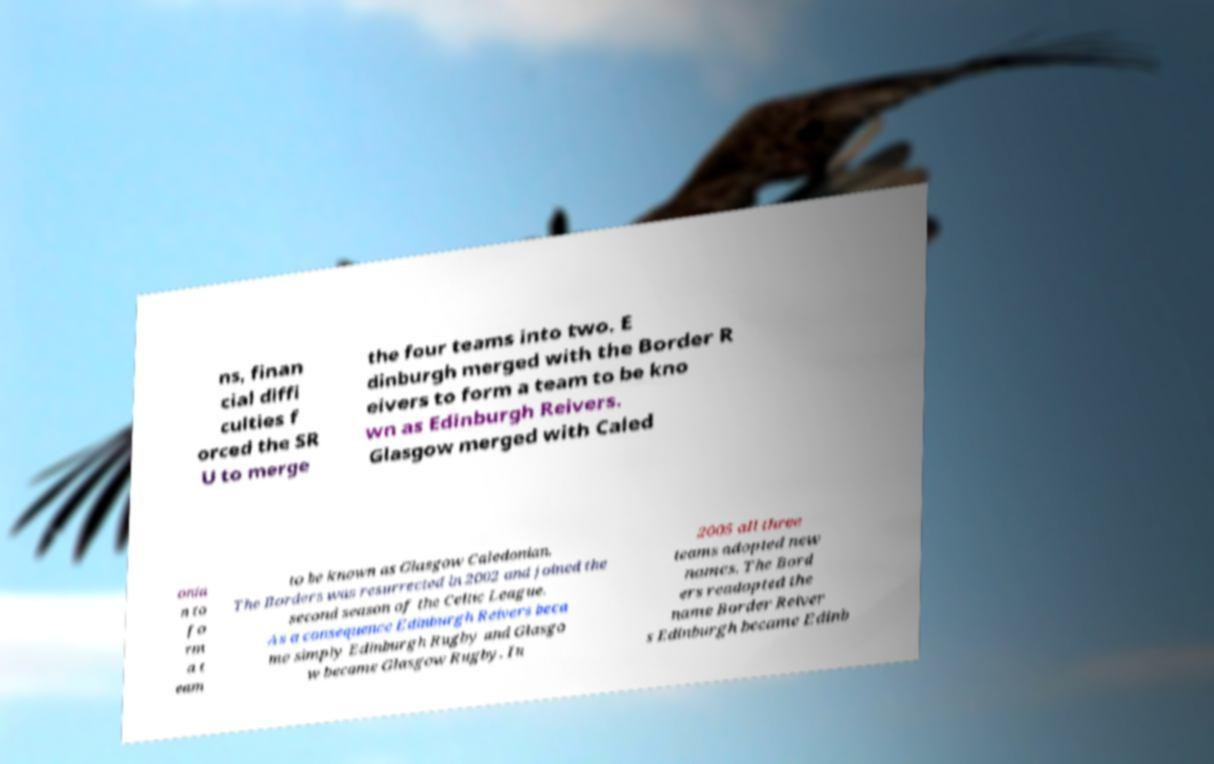There's text embedded in this image that I need extracted. Can you transcribe it verbatim? ns, finan cial diffi culties f orced the SR U to merge the four teams into two. E dinburgh merged with the Border R eivers to form a team to be kno wn as Edinburgh Reivers. Glasgow merged with Caled onia n to fo rm a t eam to be known as Glasgow Caledonian. The Borders was resurrected in 2002 and joined the second season of the Celtic League. As a consequence Edinburgh Reivers beca me simply Edinburgh Rugby and Glasgo w became Glasgow Rugby. In 2005 all three teams adopted new names. The Bord ers readopted the name Border Reiver s Edinburgh became Edinb 